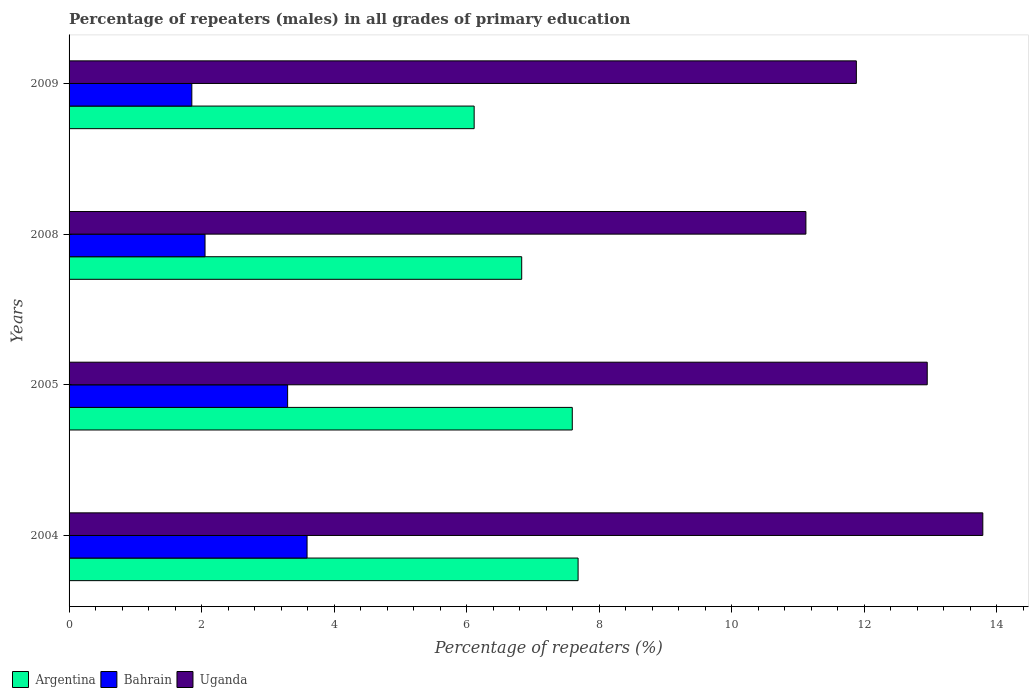How many bars are there on the 4th tick from the top?
Ensure brevity in your answer.  3. How many bars are there on the 1st tick from the bottom?
Offer a very short reply. 3. In how many cases, is the number of bars for a given year not equal to the number of legend labels?
Ensure brevity in your answer.  0. What is the percentage of repeaters (males) in Argentina in 2004?
Your answer should be compact. 7.68. Across all years, what is the maximum percentage of repeaters (males) in Uganda?
Make the answer very short. 13.79. Across all years, what is the minimum percentage of repeaters (males) in Bahrain?
Keep it short and to the point. 1.85. In which year was the percentage of repeaters (males) in Bahrain maximum?
Ensure brevity in your answer.  2004. In which year was the percentage of repeaters (males) in Argentina minimum?
Your answer should be very brief. 2009. What is the total percentage of repeaters (males) in Uganda in the graph?
Your answer should be very brief. 49.74. What is the difference between the percentage of repeaters (males) in Argentina in 2005 and that in 2008?
Ensure brevity in your answer.  0.76. What is the difference between the percentage of repeaters (males) in Argentina in 2005 and the percentage of repeaters (males) in Bahrain in 2008?
Make the answer very short. 5.54. What is the average percentage of repeaters (males) in Argentina per year?
Keep it short and to the point. 7.06. In the year 2005, what is the difference between the percentage of repeaters (males) in Bahrain and percentage of repeaters (males) in Argentina?
Your answer should be compact. -4.3. What is the ratio of the percentage of repeaters (males) in Uganda in 2005 to that in 2009?
Your answer should be compact. 1.09. Is the percentage of repeaters (males) in Uganda in 2004 less than that in 2005?
Give a very brief answer. No. What is the difference between the highest and the second highest percentage of repeaters (males) in Argentina?
Your answer should be compact. 0.09. What is the difference between the highest and the lowest percentage of repeaters (males) in Bahrain?
Your response must be concise. 1.74. Is the sum of the percentage of repeaters (males) in Bahrain in 2004 and 2009 greater than the maximum percentage of repeaters (males) in Uganda across all years?
Keep it short and to the point. No. What does the 1st bar from the top in 2008 represents?
Offer a very short reply. Uganda. What does the 2nd bar from the bottom in 2005 represents?
Ensure brevity in your answer.  Bahrain. Is it the case that in every year, the sum of the percentage of repeaters (males) in Bahrain and percentage of repeaters (males) in Argentina is greater than the percentage of repeaters (males) in Uganda?
Your answer should be compact. No. How many years are there in the graph?
Make the answer very short. 4. Are the values on the major ticks of X-axis written in scientific E-notation?
Offer a very short reply. No. Does the graph contain grids?
Your response must be concise. No. How are the legend labels stacked?
Ensure brevity in your answer.  Horizontal. What is the title of the graph?
Give a very brief answer. Percentage of repeaters (males) in all grades of primary education. What is the label or title of the X-axis?
Keep it short and to the point. Percentage of repeaters (%). What is the label or title of the Y-axis?
Your answer should be very brief. Years. What is the Percentage of repeaters (%) in Argentina in 2004?
Your answer should be compact. 7.68. What is the Percentage of repeaters (%) in Bahrain in 2004?
Ensure brevity in your answer.  3.59. What is the Percentage of repeaters (%) of Uganda in 2004?
Your response must be concise. 13.79. What is the Percentage of repeaters (%) in Argentina in 2005?
Your answer should be compact. 7.59. What is the Percentage of repeaters (%) of Bahrain in 2005?
Offer a terse response. 3.3. What is the Percentage of repeaters (%) in Uganda in 2005?
Provide a succinct answer. 12.95. What is the Percentage of repeaters (%) of Argentina in 2008?
Provide a succinct answer. 6.83. What is the Percentage of repeaters (%) of Bahrain in 2008?
Give a very brief answer. 2.05. What is the Percentage of repeaters (%) in Uganda in 2008?
Your response must be concise. 11.12. What is the Percentage of repeaters (%) of Argentina in 2009?
Your answer should be compact. 6.11. What is the Percentage of repeaters (%) in Bahrain in 2009?
Give a very brief answer. 1.85. What is the Percentage of repeaters (%) of Uganda in 2009?
Provide a short and direct response. 11.88. Across all years, what is the maximum Percentage of repeaters (%) in Argentina?
Keep it short and to the point. 7.68. Across all years, what is the maximum Percentage of repeaters (%) of Bahrain?
Make the answer very short. 3.59. Across all years, what is the maximum Percentage of repeaters (%) in Uganda?
Your response must be concise. 13.79. Across all years, what is the minimum Percentage of repeaters (%) of Argentina?
Make the answer very short. 6.11. Across all years, what is the minimum Percentage of repeaters (%) of Bahrain?
Give a very brief answer. 1.85. Across all years, what is the minimum Percentage of repeaters (%) of Uganda?
Ensure brevity in your answer.  11.12. What is the total Percentage of repeaters (%) in Argentina in the graph?
Offer a very short reply. 28.22. What is the total Percentage of repeaters (%) of Bahrain in the graph?
Give a very brief answer. 10.79. What is the total Percentage of repeaters (%) in Uganda in the graph?
Make the answer very short. 49.74. What is the difference between the Percentage of repeaters (%) in Argentina in 2004 and that in 2005?
Provide a succinct answer. 0.09. What is the difference between the Percentage of repeaters (%) of Bahrain in 2004 and that in 2005?
Provide a short and direct response. 0.29. What is the difference between the Percentage of repeaters (%) of Uganda in 2004 and that in 2005?
Keep it short and to the point. 0.84. What is the difference between the Percentage of repeaters (%) of Argentina in 2004 and that in 2008?
Offer a very short reply. 0.85. What is the difference between the Percentage of repeaters (%) in Bahrain in 2004 and that in 2008?
Your answer should be compact. 1.54. What is the difference between the Percentage of repeaters (%) in Uganda in 2004 and that in 2008?
Your answer should be compact. 2.67. What is the difference between the Percentage of repeaters (%) of Argentina in 2004 and that in 2009?
Offer a very short reply. 1.57. What is the difference between the Percentage of repeaters (%) in Bahrain in 2004 and that in 2009?
Offer a terse response. 1.74. What is the difference between the Percentage of repeaters (%) in Uganda in 2004 and that in 2009?
Your answer should be very brief. 1.91. What is the difference between the Percentage of repeaters (%) in Argentina in 2005 and that in 2008?
Your answer should be very brief. 0.76. What is the difference between the Percentage of repeaters (%) of Bahrain in 2005 and that in 2008?
Give a very brief answer. 1.25. What is the difference between the Percentage of repeaters (%) in Uganda in 2005 and that in 2008?
Offer a terse response. 1.83. What is the difference between the Percentage of repeaters (%) of Argentina in 2005 and that in 2009?
Provide a succinct answer. 1.48. What is the difference between the Percentage of repeaters (%) of Bahrain in 2005 and that in 2009?
Offer a terse response. 1.45. What is the difference between the Percentage of repeaters (%) in Uganda in 2005 and that in 2009?
Make the answer very short. 1.07. What is the difference between the Percentage of repeaters (%) of Argentina in 2008 and that in 2009?
Your response must be concise. 0.72. What is the difference between the Percentage of repeaters (%) of Bahrain in 2008 and that in 2009?
Make the answer very short. 0.2. What is the difference between the Percentage of repeaters (%) of Uganda in 2008 and that in 2009?
Give a very brief answer. -0.76. What is the difference between the Percentage of repeaters (%) in Argentina in 2004 and the Percentage of repeaters (%) in Bahrain in 2005?
Your answer should be very brief. 4.38. What is the difference between the Percentage of repeaters (%) in Argentina in 2004 and the Percentage of repeaters (%) in Uganda in 2005?
Your response must be concise. -5.27. What is the difference between the Percentage of repeaters (%) of Bahrain in 2004 and the Percentage of repeaters (%) of Uganda in 2005?
Give a very brief answer. -9.36. What is the difference between the Percentage of repeaters (%) of Argentina in 2004 and the Percentage of repeaters (%) of Bahrain in 2008?
Offer a terse response. 5.63. What is the difference between the Percentage of repeaters (%) in Argentina in 2004 and the Percentage of repeaters (%) in Uganda in 2008?
Keep it short and to the point. -3.44. What is the difference between the Percentage of repeaters (%) in Bahrain in 2004 and the Percentage of repeaters (%) in Uganda in 2008?
Provide a succinct answer. -7.53. What is the difference between the Percentage of repeaters (%) in Argentina in 2004 and the Percentage of repeaters (%) in Bahrain in 2009?
Offer a terse response. 5.83. What is the difference between the Percentage of repeaters (%) in Argentina in 2004 and the Percentage of repeaters (%) in Uganda in 2009?
Your answer should be compact. -4.2. What is the difference between the Percentage of repeaters (%) in Bahrain in 2004 and the Percentage of repeaters (%) in Uganda in 2009?
Your response must be concise. -8.29. What is the difference between the Percentage of repeaters (%) of Argentina in 2005 and the Percentage of repeaters (%) of Bahrain in 2008?
Your answer should be compact. 5.54. What is the difference between the Percentage of repeaters (%) of Argentina in 2005 and the Percentage of repeaters (%) of Uganda in 2008?
Keep it short and to the point. -3.53. What is the difference between the Percentage of repeaters (%) in Bahrain in 2005 and the Percentage of repeaters (%) in Uganda in 2008?
Give a very brief answer. -7.82. What is the difference between the Percentage of repeaters (%) of Argentina in 2005 and the Percentage of repeaters (%) of Bahrain in 2009?
Provide a succinct answer. 5.74. What is the difference between the Percentage of repeaters (%) in Argentina in 2005 and the Percentage of repeaters (%) in Uganda in 2009?
Your answer should be compact. -4.29. What is the difference between the Percentage of repeaters (%) in Bahrain in 2005 and the Percentage of repeaters (%) in Uganda in 2009?
Your answer should be very brief. -8.58. What is the difference between the Percentage of repeaters (%) of Argentina in 2008 and the Percentage of repeaters (%) of Bahrain in 2009?
Offer a very short reply. 4.98. What is the difference between the Percentage of repeaters (%) in Argentina in 2008 and the Percentage of repeaters (%) in Uganda in 2009?
Offer a terse response. -5.05. What is the difference between the Percentage of repeaters (%) of Bahrain in 2008 and the Percentage of repeaters (%) of Uganda in 2009?
Make the answer very short. -9.83. What is the average Percentage of repeaters (%) in Argentina per year?
Your answer should be very brief. 7.06. What is the average Percentage of repeaters (%) of Bahrain per year?
Offer a terse response. 2.7. What is the average Percentage of repeaters (%) of Uganda per year?
Provide a succinct answer. 12.44. In the year 2004, what is the difference between the Percentage of repeaters (%) in Argentina and Percentage of repeaters (%) in Bahrain?
Offer a very short reply. 4.09. In the year 2004, what is the difference between the Percentage of repeaters (%) in Argentina and Percentage of repeaters (%) in Uganda?
Keep it short and to the point. -6.11. In the year 2004, what is the difference between the Percentage of repeaters (%) of Bahrain and Percentage of repeaters (%) of Uganda?
Your answer should be compact. -10.2. In the year 2005, what is the difference between the Percentage of repeaters (%) in Argentina and Percentage of repeaters (%) in Bahrain?
Keep it short and to the point. 4.3. In the year 2005, what is the difference between the Percentage of repeaters (%) in Argentina and Percentage of repeaters (%) in Uganda?
Keep it short and to the point. -5.36. In the year 2005, what is the difference between the Percentage of repeaters (%) in Bahrain and Percentage of repeaters (%) in Uganda?
Offer a terse response. -9.65. In the year 2008, what is the difference between the Percentage of repeaters (%) of Argentina and Percentage of repeaters (%) of Bahrain?
Ensure brevity in your answer.  4.78. In the year 2008, what is the difference between the Percentage of repeaters (%) in Argentina and Percentage of repeaters (%) in Uganda?
Provide a short and direct response. -4.29. In the year 2008, what is the difference between the Percentage of repeaters (%) of Bahrain and Percentage of repeaters (%) of Uganda?
Keep it short and to the point. -9.07. In the year 2009, what is the difference between the Percentage of repeaters (%) in Argentina and Percentage of repeaters (%) in Bahrain?
Keep it short and to the point. 4.26. In the year 2009, what is the difference between the Percentage of repeaters (%) in Argentina and Percentage of repeaters (%) in Uganda?
Keep it short and to the point. -5.77. In the year 2009, what is the difference between the Percentage of repeaters (%) of Bahrain and Percentage of repeaters (%) of Uganda?
Ensure brevity in your answer.  -10.03. What is the ratio of the Percentage of repeaters (%) of Argentina in 2004 to that in 2005?
Your response must be concise. 1.01. What is the ratio of the Percentage of repeaters (%) of Bahrain in 2004 to that in 2005?
Make the answer very short. 1.09. What is the ratio of the Percentage of repeaters (%) of Uganda in 2004 to that in 2005?
Your response must be concise. 1.06. What is the ratio of the Percentage of repeaters (%) in Argentina in 2004 to that in 2008?
Keep it short and to the point. 1.12. What is the ratio of the Percentage of repeaters (%) of Bahrain in 2004 to that in 2008?
Make the answer very short. 1.75. What is the ratio of the Percentage of repeaters (%) of Uganda in 2004 to that in 2008?
Offer a terse response. 1.24. What is the ratio of the Percentage of repeaters (%) of Argentina in 2004 to that in 2009?
Give a very brief answer. 1.26. What is the ratio of the Percentage of repeaters (%) in Bahrain in 2004 to that in 2009?
Your response must be concise. 1.94. What is the ratio of the Percentage of repeaters (%) of Uganda in 2004 to that in 2009?
Offer a very short reply. 1.16. What is the ratio of the Percentage of repeaters (%) of Argentina in 2005 to that in 2008?
Offer a terse response. 1.11. What is the ratio of the Percentage of repeaters (%) of Bahrain in 2005 to that in 2008?
Your answer should be very brief. 1.61. What is the ratio of the Percentage of repeaters (%) of Uganda in 2005 to that in 2008?
Your answer should be very brief. 1.16. What is the ratio of the Percentage of repeaters (%) of Argentina in 2005 to that in 2009?
Provide a succinct answer. 1.24. What is the ratio of the Percentage of repeaters (%) in Bahrain in 2005 to that in 2009?
Your answer should be very brief. 1.78. What is the ratio of the Percentage of repeaters (%) of Uganda in 2005 to that in 2009?
Ensure brevity in your answer.  1.09. What is the ratio of the Percentage of repeaters (%) in Argentina in 2008 to that in 2009?
Provide a short and direct response. 1.12. What is the ratio of the Percentage of repeaters (%) of Bahrain in 2008 to that in 2009?
Your answer should be compact. 1.11. What is the ratio of the Percentage of repeaters (%) of Uganda in 2008 to that in 2009?
Provide a short and direct response. 0.94. What is the difference between the highest and the second highest Percentage of repeaters (%) of Argentina?
Provide a short and direct response. 0.09. What is the difference between the highest and the second highest Percentage of repeaters (%) in Bahrain?
Your answer should be very brief. 0.29. What is the difference between the highest and the second highest Percentage of repeaters (%) in Uganda?
Provide a short and direct response. 0.84. What is the difference between the highest and the lowest Percentage of repeaters (%) in Argentina?
Give a very brief answer. 1.57. What is the difference between the highest and the lowest Percentage of repeaters (%) of Bahrain?
Give a very brief answer. 1.74. What is the difference between the highest and the lowest Percentage of repeaters (%) of Uganda?
Keep it short and to the point. 2.67. 